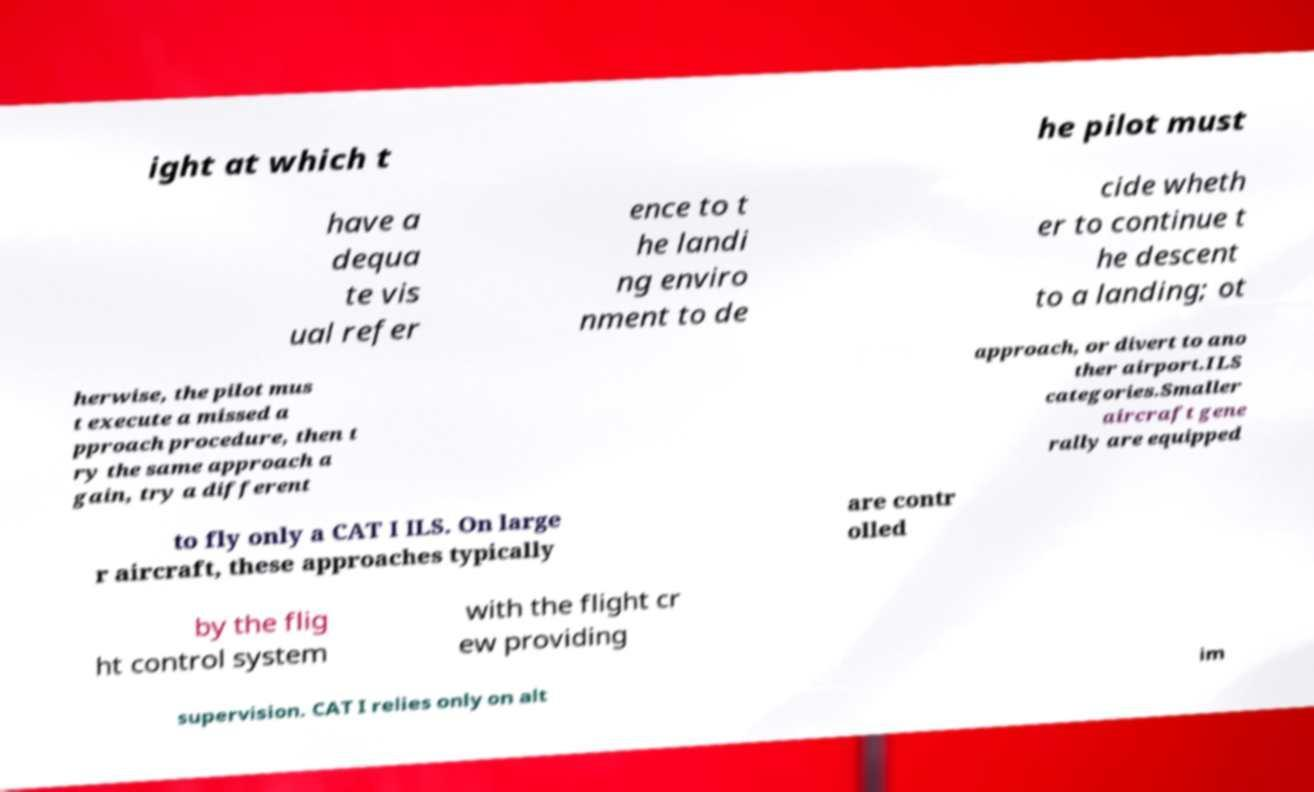Please identify and transcribe the text found in this image. ight at which t he pilot must have a dequa te vis ual refer ence to t he landi ng enviro nment to de cide wheth er to continue t he descent to a landing; ot herwise, the pilot mus t execute a missed a pproach procedure, then t ry the same approach a gain, try a different approach, or divert to ano ther airport.ILS categories.Smaller aircraft gene rally are equipped to fly only a CAT I ILS. On large r aircraft, these approaches typically are contr olled by the flig ht control system with the flight cr ew providing supervision. CAT I relies only on alt im 